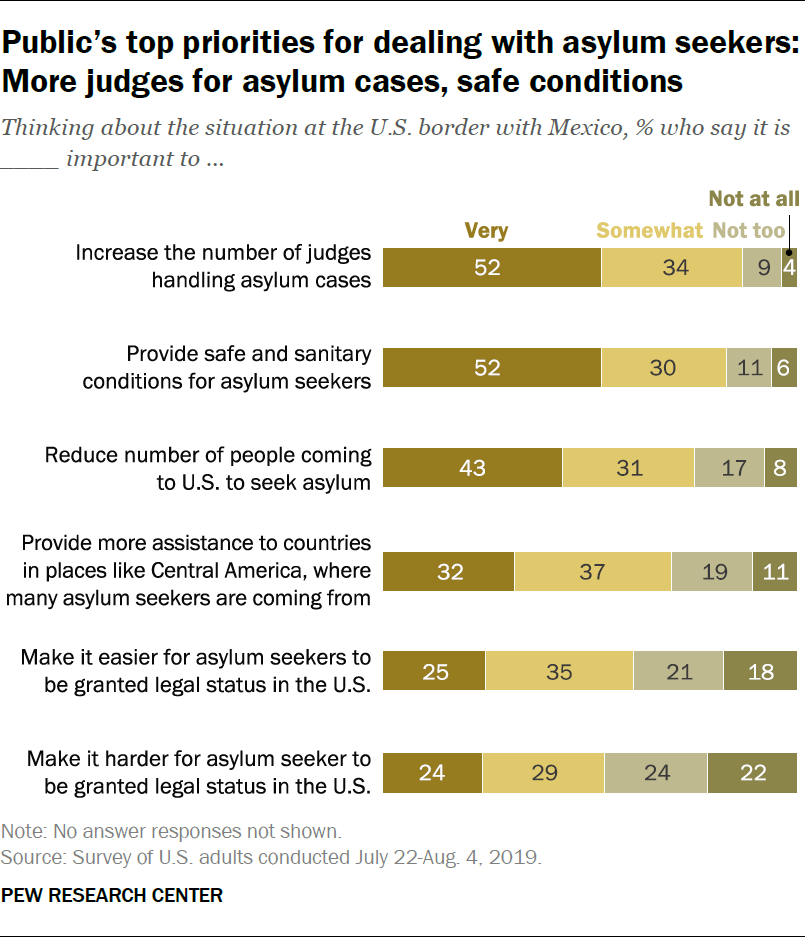Identify some key points in this picture. Yes, there are two bars whose value remains the same. The value of the smallest grey bar is 9. 